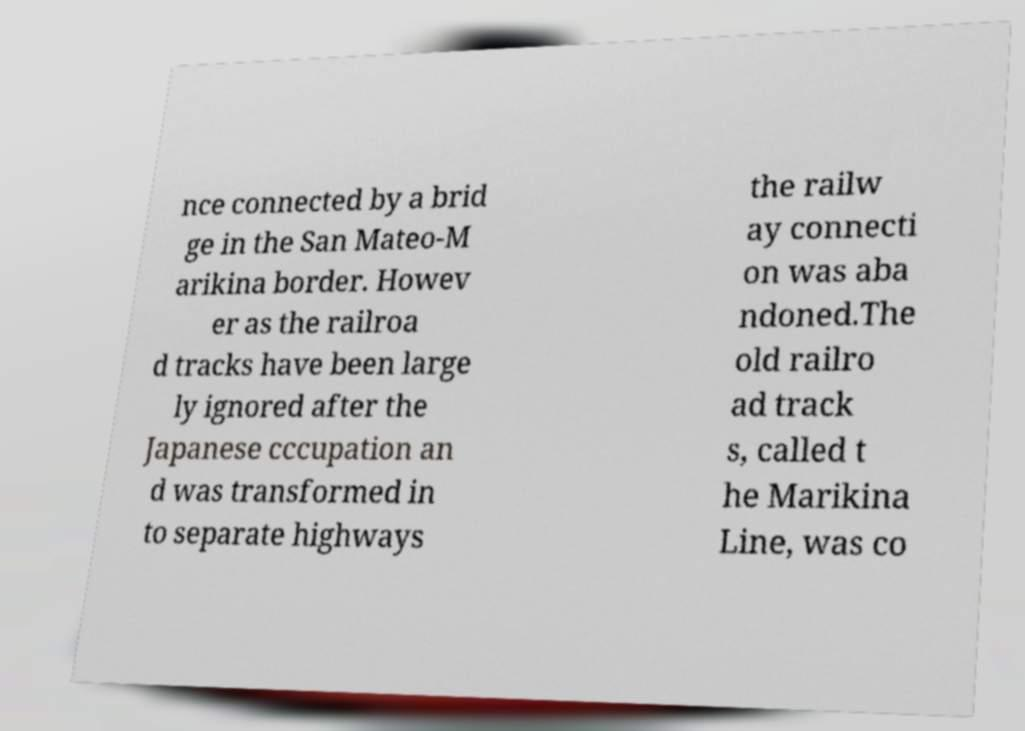Can you accurately transcribe the text from the provided image for me? nce connected by a brid ge in the San Mateo-M arikina border. Howev er as the railroa d tracks have been large ly ignored after the Japanese cccupation an d was transformed in to separate highways the railw ay connecti on was aba ndoned.The old railro ad track s, called t he Marikina Line, was co 